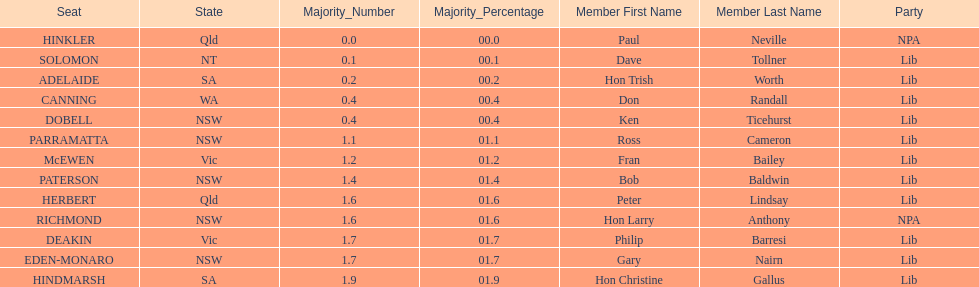Was fran bailey from vic or wa? Vic. 